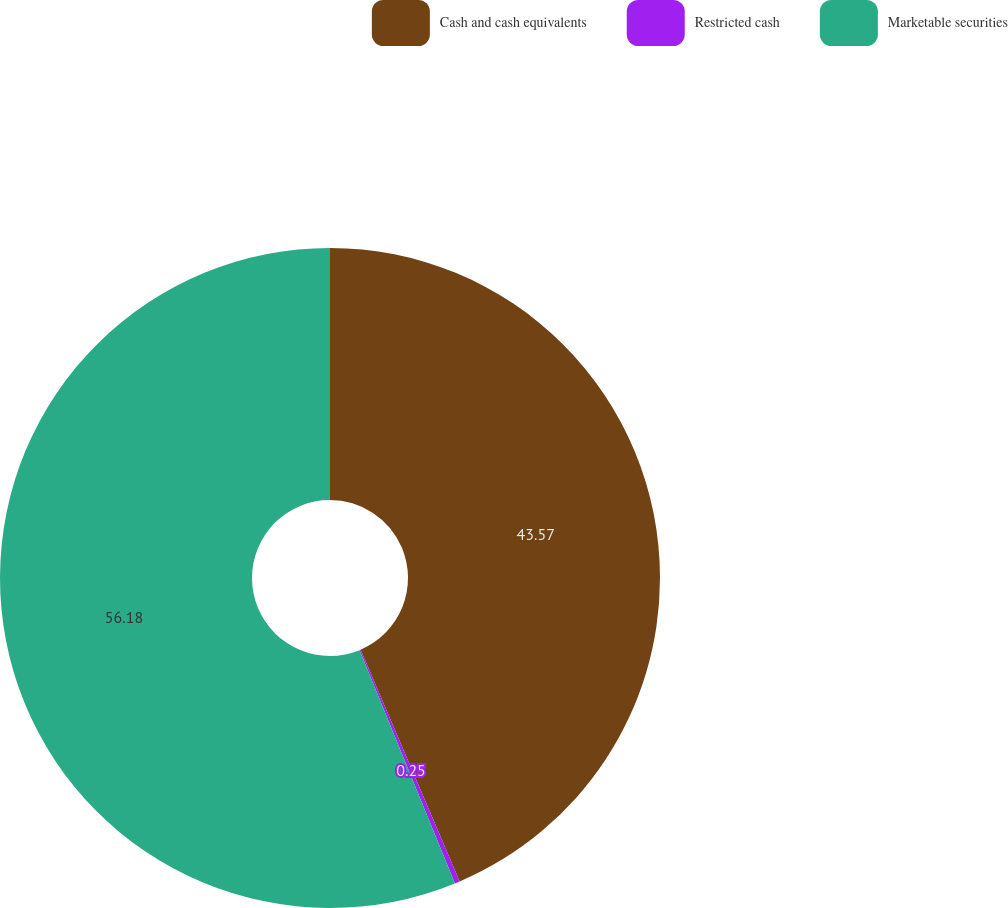Convert chart. <chart><loc_0><loc_0><loc_500><loc_500><pie_chart><fcel>Cash and cash equivalents<fcel>Restricted cash<fcel>Marketable securities<nl><fcel>43.57%<fcel>0.25%<fcel>56.18%<nl></chart> 